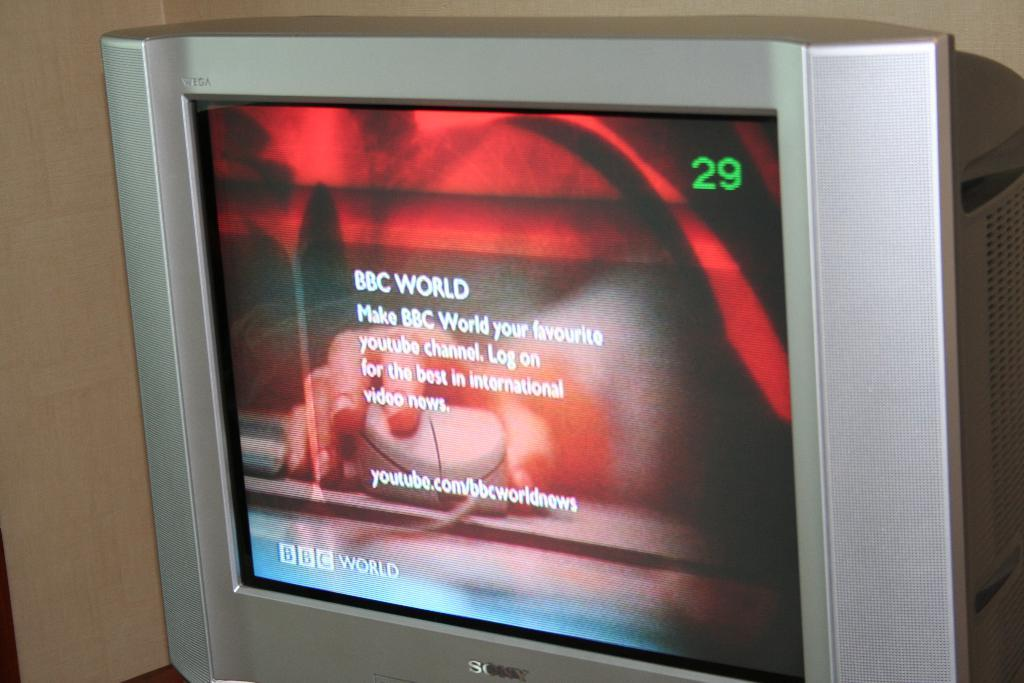Provide a one-sentence caption for the provided image. a monitor on channel 29 shows a news snippit by BBC WORLD. 